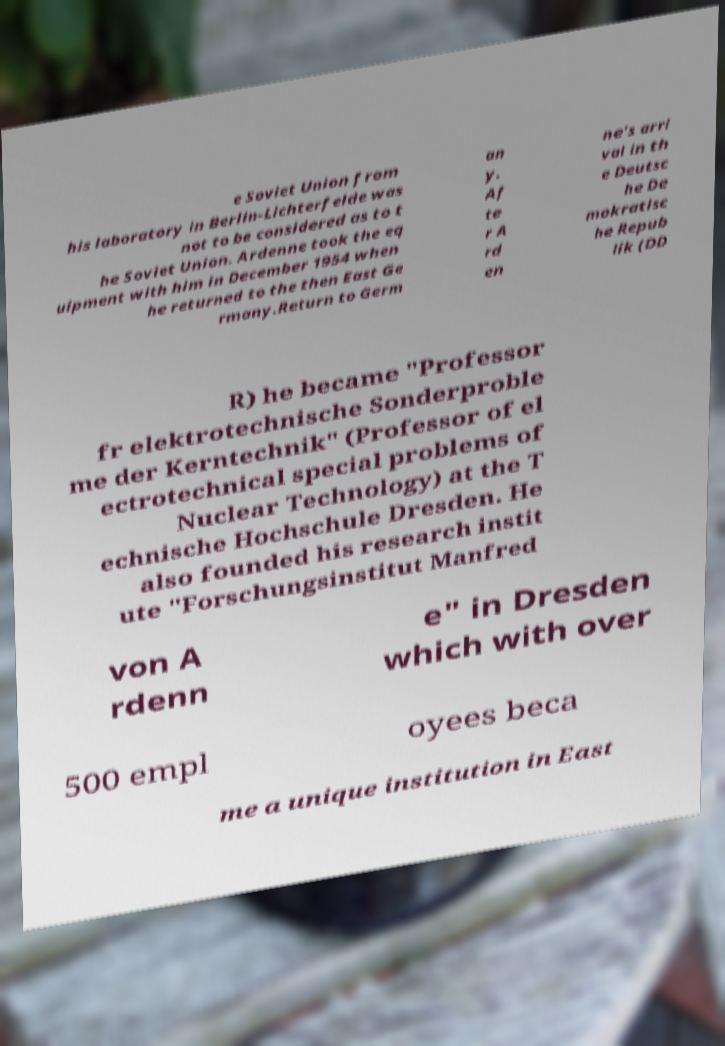What messages or text are displayed in this image? I need them in a readable, typed format. e Soviet Union from his laboratory in Berlin-Lichterfelde was not to be considered as to t he Soviet Union. Ardenne took the eq uipment with him in December 1954 when he returned to the then East Ge rmany.Return to Germ an y. Af te r A rd en ne's arri val in th e Deutsc he De mokratisc he Repub lik (DD R) he became "Professor fr elektrotechnische Sonderproble me der Kerntechnik" (Professor of el ectrotechnical special problems of Nuclear Technology) at the T echnische Hochschule Dresden. He also founded his research instit ute "Forschungsinstitut Manfred von A rdenn e" in Dresden which with over 500 empl oyees beca me a unique institution in East 